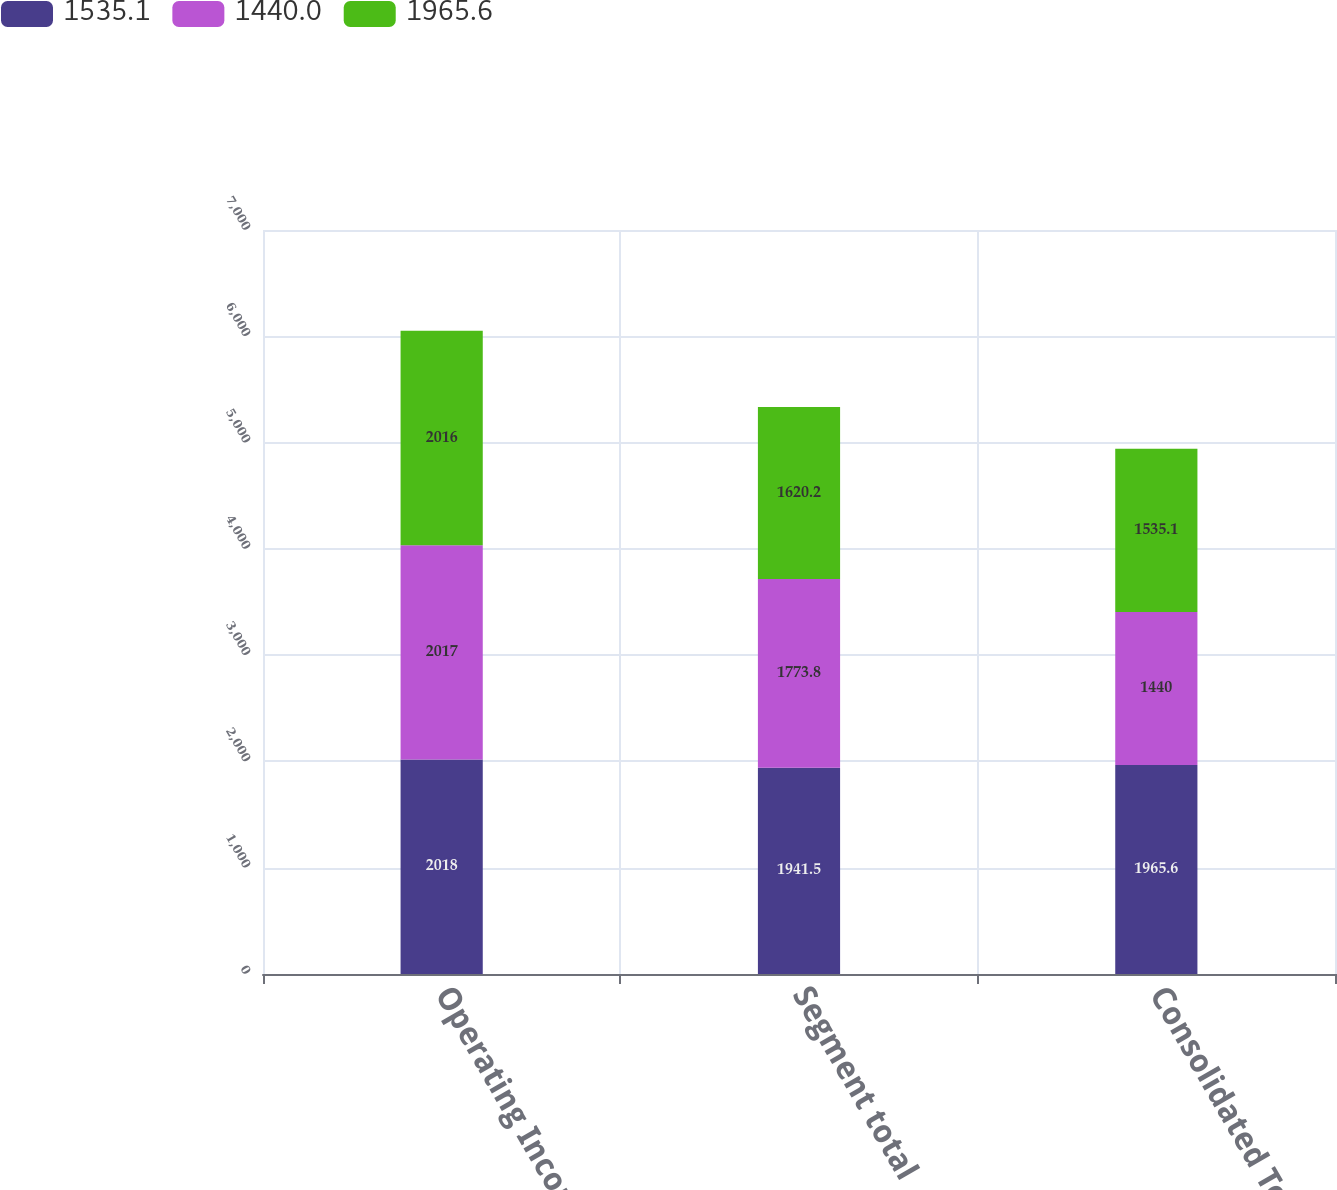<chart> <loc_0><loc_0><loc_500><loc_500><stacked_bar_chart><ecel><fcel>Operating Income<fcel>Segment total<fcel>Consolidated Total<nl><fcel>1535.1<fcel>2018<fcel>1941.5<fcel>1965.6<nl><fcel>1440<fcel>2017<fcel>1773.8<fcel>1440<nl><fcel>1965.6<fcel>2016<fcel>1620.2<fcel>1535.1<nl></chart> 